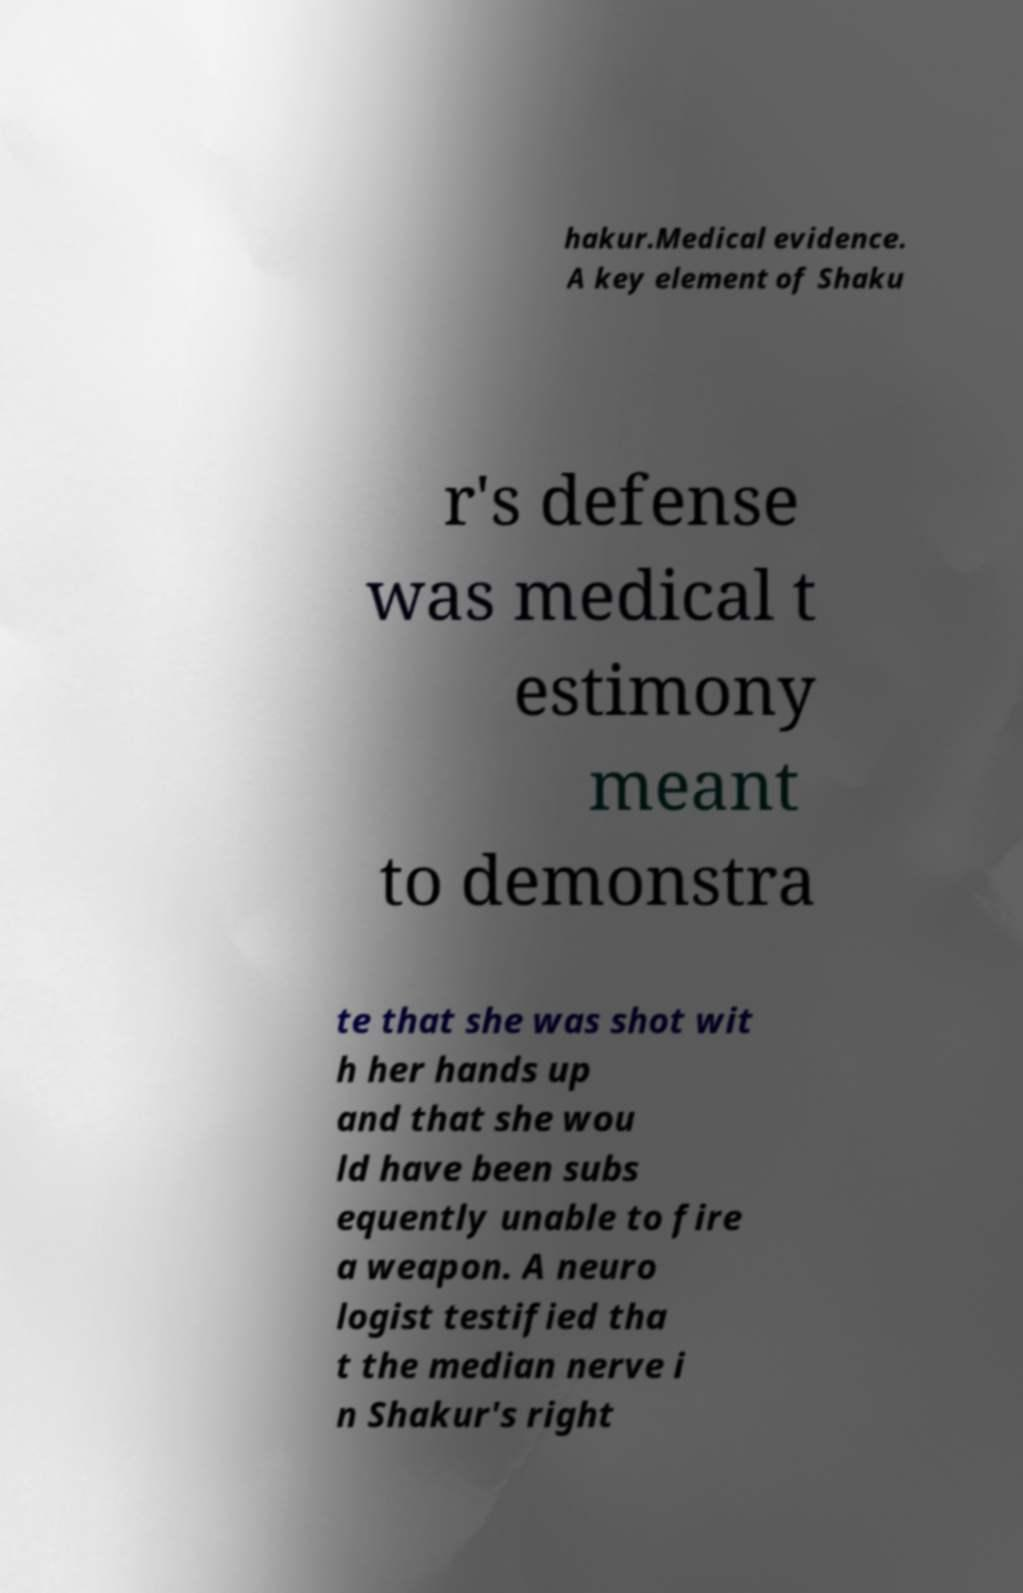Can you accurately transcribe the text from the provided image for me? hakur.Medical evidence. A key element of Shaku r's defense was medical t estimony meant to demonstra te that she was shot wit h her hands up and that she wou ld have been subs equently unable to fire a weapon. A neuro logist testified tha t the median nerve i n Shakur's right 